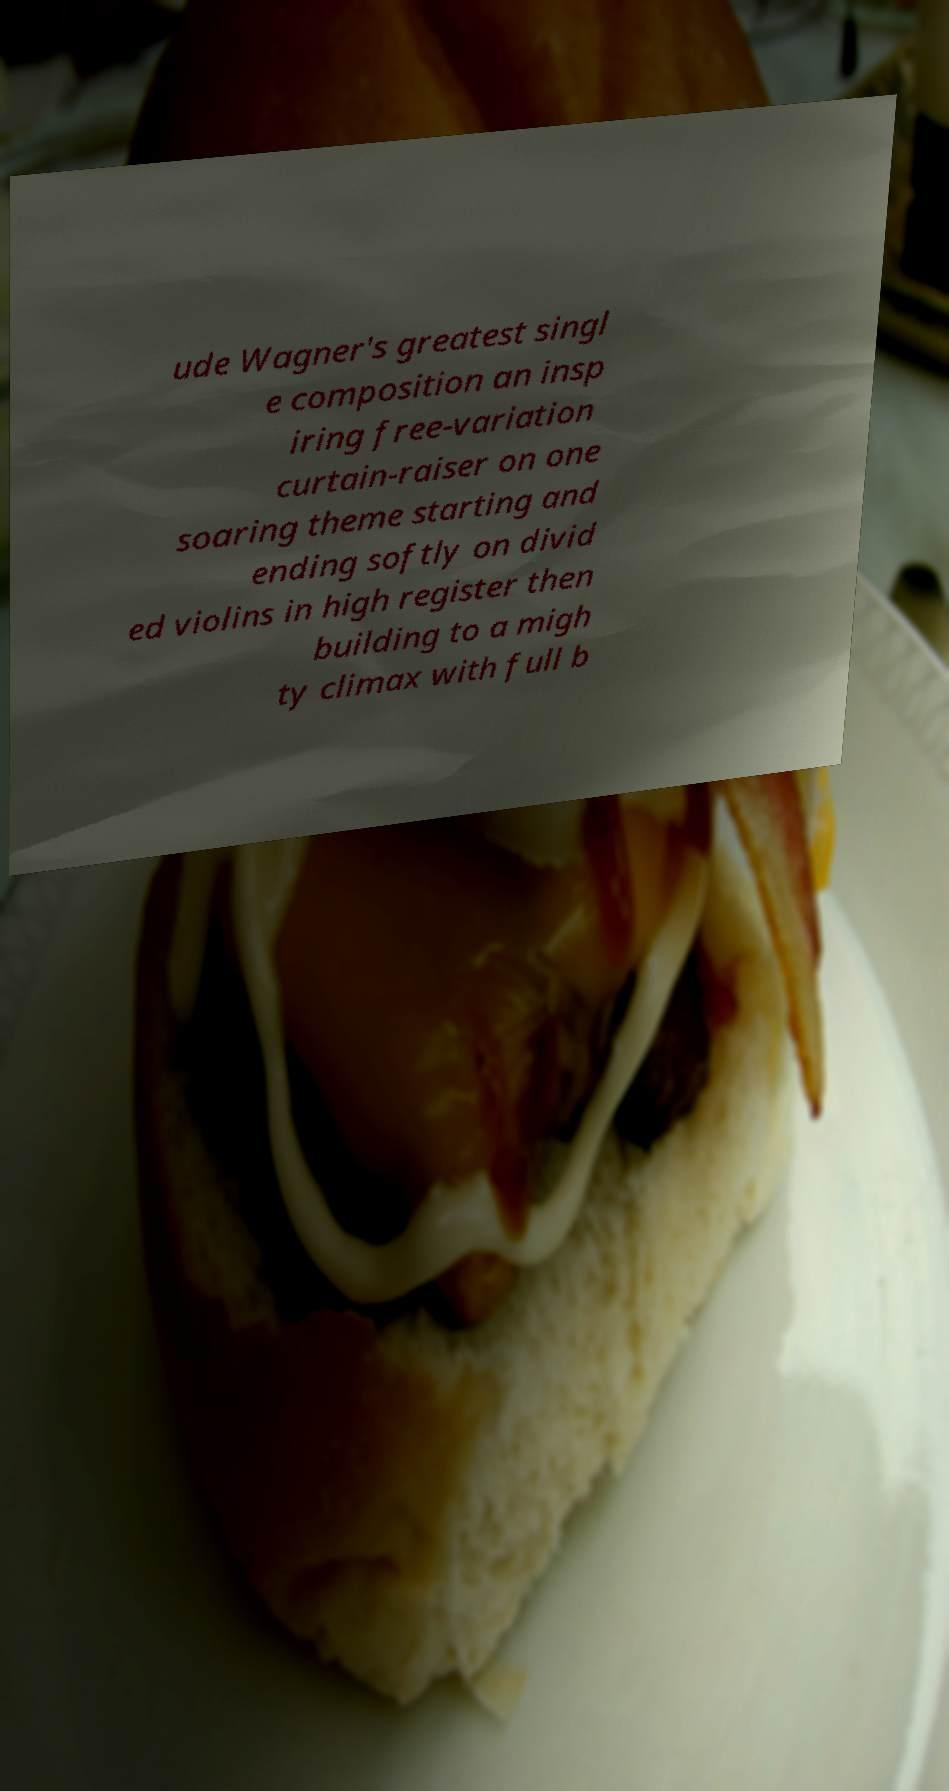Could you extract and type out the text from this image? ude Wagner's greatest singl e composition an insp iring free-variation curtain-raiser on one soaring theme starting and ending softly on divid ed violins in high register then building to a migh ty climax with full b 